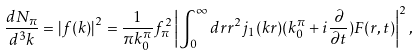<formula> <loc_0><loc_0><loc_500><loc_500>\frac { d N _ { \pi } } { d ^ { 3 } k } = \left | f ( k ) \right | ^ { 2 } = \frac { 1 } { \pi k _ { 0 } ^ { \pi } } f _ { \pi } ^ { 2 } \left | \int _ { 0 } ^ { \infty } d r r ^ { 2 } j _ { 1 } ( k r ) ( k _ { 0 } ^ { \pi } + i \frac { \partial } { \partial t } ) F ( r , t ) \right | ^ { 2 } ,</formula> 